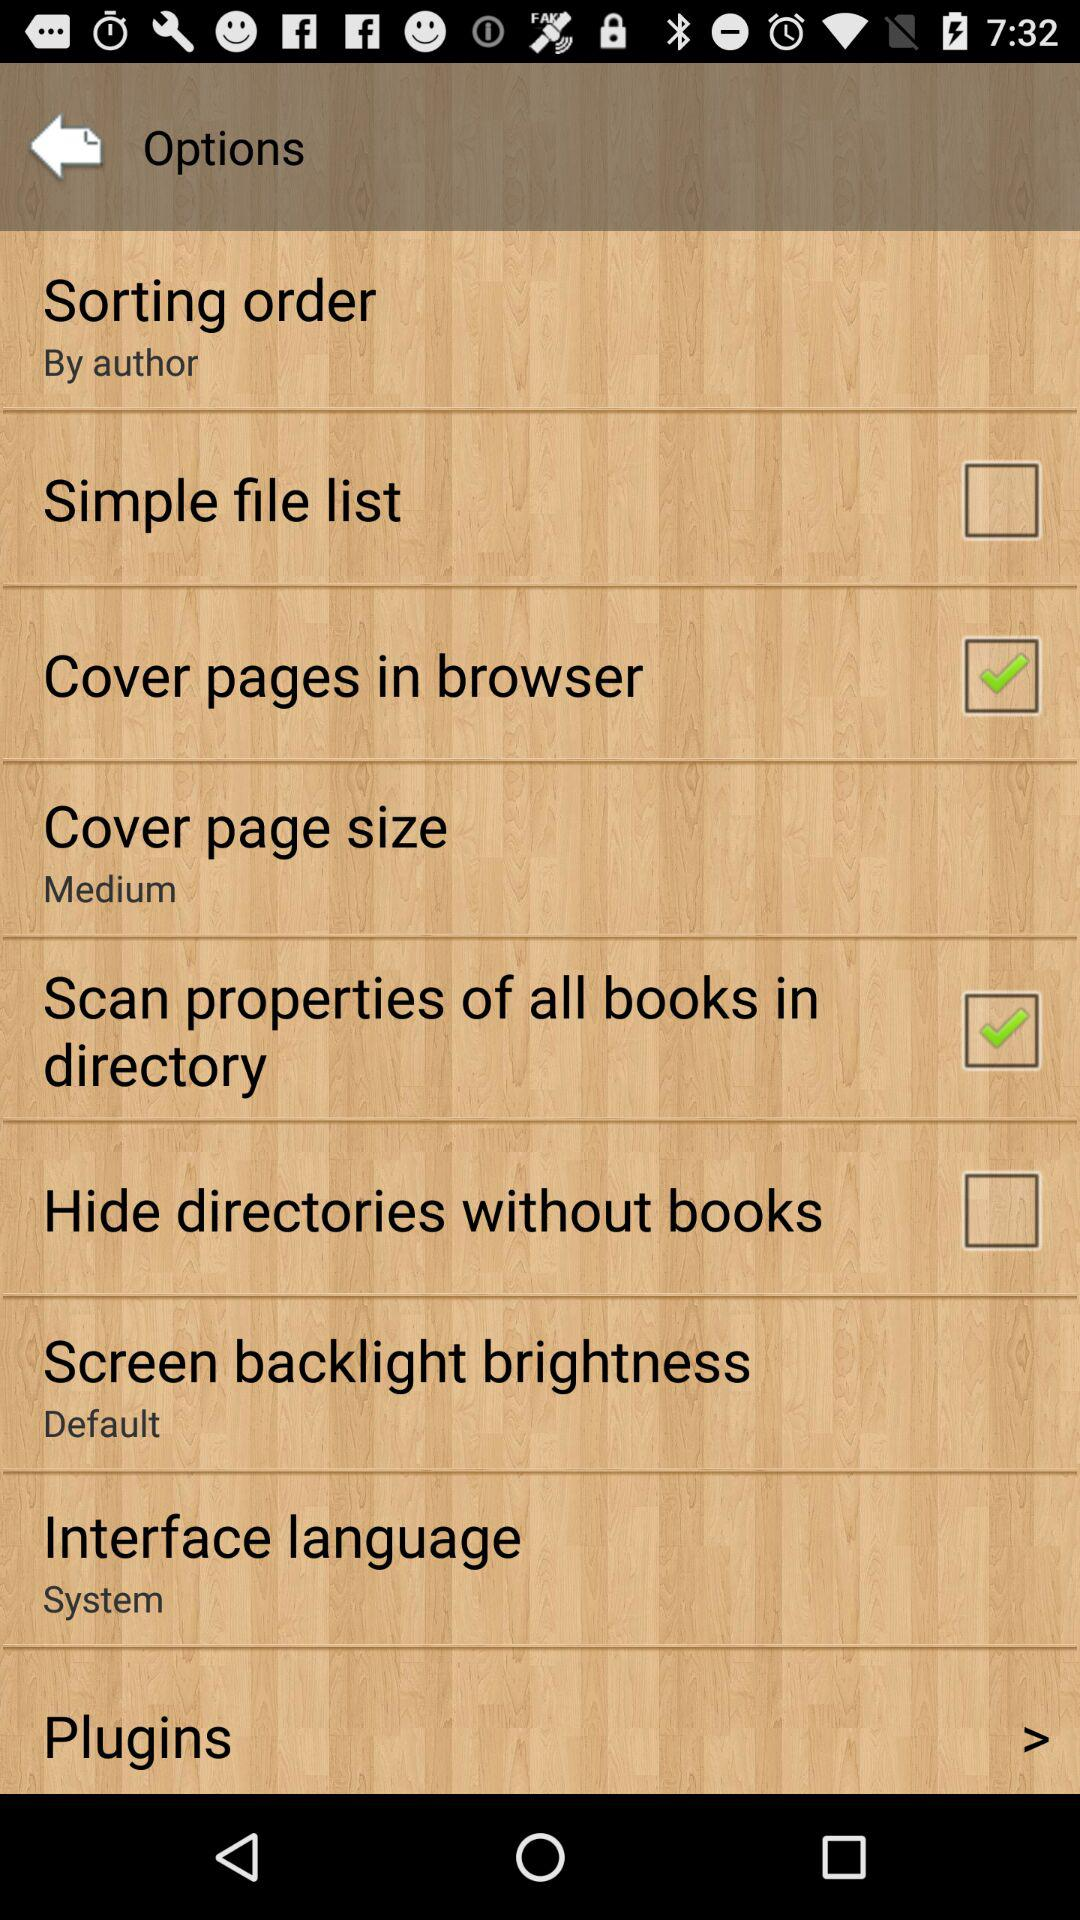Which options are selected in the application? The selected options are "Cover pages in browser" and "Scan properties of all books in directory". 